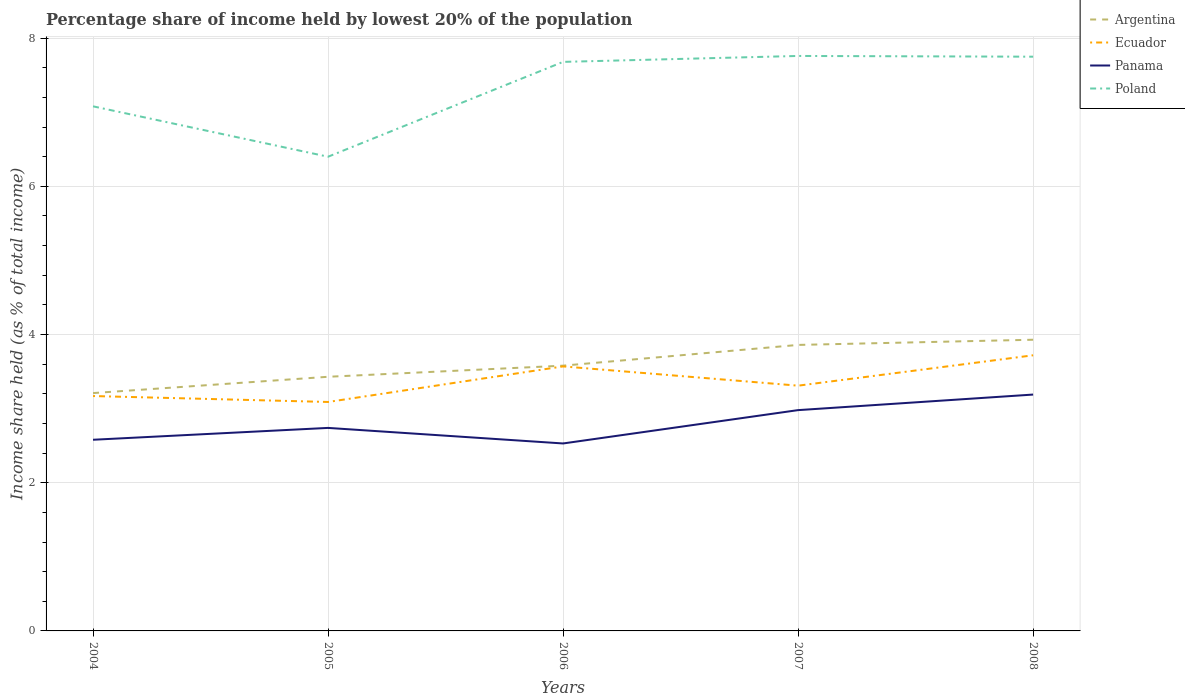Across all years, what is the maximum percentage share of income held by lowest 20% of the population in Poland?
Offer a terse response. 6.4. In which year was the percentage share of income held by lowest 20% of the population in Argentina maximum?
Make the answer very short. 2004. What is the total percentage share of income held by lowest 20% of the population in Argentina in the graph?
Give a very brief answer. -0.5. What is the difference between the highest and the second highest percentage share of income held by lowest 20% of the population in Argentina?
Your response must be concise. 0.72. What is the difference between the highest and the lowest percentage share of income held by lowest 20% of the population in Argentina?
Give a very brief answer. 2. What is the difference between two consecutive major ticks on the Y-axis?
Your response must be concise. 2. How are the legend labels stacked?
Your answer should be compact. Vertical. What is the title of the graph?
Make the answer very short. Percentage share of income held by lowest 20% of the population. What is the label or title of the X-axis?
Provide a succinct answer. Years. What is the label or title of the Y-axis?
Offer a very short reply. Income share held (as % of total income). What is the Income share held (as % of total income) in Argentina in 2004?
Ensure brevity in your answer.  3.21. What is the Income share held (as % of total income) in Ecuador in 2004?
Ensure brevity in your answer.  3.17. What is the Income share held (as % of total income) of Panama in 2004?
Provide a succinct answer. 2.58. What is the Income share held (as % of total income) in Poland in 2004?
Offer a very short reply. 7.08. What is the Income share held (as % of total income) of Argentina in 2005?
Give a very brief answer. 3.43. What is the Income share held (as % of total income) of Ecuador in 2005?
Your response must be concise. 3.09. What is the Income share held (as % of total income) in Panama in 2005?
Keep it short and to the point. 2.74. What is the Income share held (as % of total income) of Poland in 2005?
Provide a short and direct response. 6.4. What is the Income share held (as % of total income) in Argentina in 2006?
Provide a short and direct response. 3.58. What is the Income share held (as % of total income) in Ecuador in 2006?
Make the answer very short. 3.57. What is the Income share held (as % of total income) in Panama in 2006?
Offer a terse response. 2.53. What is the Income share held (as % of total income) of Poland in 2006?
Offer a terse response. 7.68. What is the Income share held (as % of total income) of Argentina in 2007?
Your answer should be compact. 3.86. What is the Income share held (as % of total income) in Ecuador in 2007?
Your response must be concise. 3.31. What is the Income share held (as % of total income) of Panama in 2007?
Keep it short and to the point. 2.98. What is the Income share held (as % of total income) in Poland in 2007?
Give a very brief answer. 7.76. What is the Income share held (as % of total income) of Argentina in 2008?
Ensure brevity in your answer.  3.93. What is the Income share held (as % of total income) of Ecuador in 2008?
Your answer should be compact. 3.72. What is the Income share held (as % of total income) in Panama in 2008?
Your answer should be very brief. 3.19. What is the Income share held (as % of total income) in Poland in 2008?
Offer a terse response. 7.75. Across all years, what is the maximum Income share held (as % of total income) in Argentina?
Your answer should be compact. 3.93. Across all years, what is the maximum Income share held (as % of total income) of Ecuador?
Give a very brief answer. 3.72. Across all years, what is the maximum Income share held (as % of total income) of Panama?
Your response must be concise. 3.19. Across all years, what is the maximum Income share held (as % of total income) in Poland?
Provide a succinct answer. 7.76. Across all years, what is the minimum Income share held (as % of total income) in Argentina?
Give a very brief answer. 3.21. Across all years, what is the minimum Income share held (as % of total income) in Ecuador?
Make the answer very short. 3.09. Across all years, what is the minimum Income share held (as % of total income) in Panama?
Provide a succinct answer. 2.53. Across all years, what is the minimum Income share held (as % of total income) in Poland?
Give a very brief answer. 6.4. What is the total Income share held (as % of total income) of Argentina in the graph?
Your answer should be compact. 18.01. What is the total Income share held (as % of total income) in Ecuador in the graph?
Ensure brevity in your answer.  16.86. What is the total Income share held (as % of total income) of Panama in the graph?
Ensure brevity in your answer.  14.02. What is the total Income share held (as % of total income) in Poland in the graph?
Make the answer very short. 36.67. What is the difference between the Income share held (as % of total income) in Argentina in 2004 and that in 2005?
Give a very brief answer. -0.22. What is the difference between the Income share held (as % of total income) of Panama in 2004 and that in 2005?
Give a very brief answer. -0.16. What is the difference between the Income share held (as % of total income) in Poland in 2004 and that in 2005?
Your answer should be very brief. 0.68. What is the difference between the Income share held (as % of total income) of Argentina in 2004 and that in 2006?
Make the answer very short. -0.37. What is the difference between the Income share held (as % of total income) of Panama in 2004 and that in 2006?
Your answer should be very brief. 0.05. What is the difference between the Income share held (as % of total income) of Poland in 2004 and that in 2006?
Keep it short and to the point. -0.6. What is the difference between the Income share held (as % of total income) in Argentina in 2004 and that in 2007?
Provide a short and direct response. -0.65. What is the difference between the Income share held (as % of total income) in Ecuador in 2004 and that in 2007?
Give a very brief answer. -0.14. What is the difference between the Income share held (as % of total income) of Panama in 2004 and that in 2007?
Make the answer very short. -0.4. What is the difference between the Income share held (as % of total income) in Poland in 2004 and that in 2007?
Make the answer very short. -0.68. What is the difference between the Income share held (as % of total income) of Argentina in 2004 and that in 2008?
Ensure brevity in your answer.  -0.72. What is the difference between the Income share held (as % of total income) in Ecuador in 2004 and that in 2008?
Keep it short and to the point. -0.55. What is the difference between the Income share held (as % of total income) in Panama in 2004 and that in 2008?
Your answer should be very brief. -0.61. What is the difference between the Income share held (as % of total income) in Poland in 2004 and that in 2008?
Provide a short and direct response. -0.67. What is the difference between the Income share held (as % of total income) in Ecuador in 2005 and that in 2006?
Ensure brevity in your answer.  -0.48. What is the difference between the Income share held (as % of total income) of Panama in 2005 and that in 2006?
Give a very brief answer. 0.21. What is the difference between the Income share held (as % of total income) of Poland in 2005 and that in 2006?
Provide a short and direct response. -1.28. What is the difference between the Income share held (as % of total income) of Argentina in 2005 and that in 2007?
Your answer should be compact. -0.43. What is the difference between the Income share held (as % of total income) of Ecuador in 2005 and that in 2007?
Offer a terse response. -0.22. What is the difference between the Income share held (as % of total income) in Panama in 2005 and that in 2007?
Ensure brevity in your answer.  -0.24. What is the difference between the Income share held (as % of total income) of Poland in 2005 and that in 2007?
Offer a very short reply. -1.36. What is the difference between the Income share held (as % of total income) of Argentina in 2005 and that in 2008?
Provide a succinct answer. -0.5. What is the difference between the Income share held (as % of total income) in Ecuador in 2005 and that in 2008?
Offer a very short reply. -0.63. What is the difference between the Income share held (as % of total income) of Panama in 2005 and that in 2008?
Give a very brief answer. -0.45. What is the difference between the Income share held (as % of total income) of Poland in 2005 and that in 2008?
Your response must be concise. -1.35. What is the difference between the Income share held (as % of total income) of Argentina in 2006 and that in 2007?
Make the answer very short. -0.28. What is the difference between the Income share held (as % of total income) in Ecuador in 2006 and that in 2007?
Make the answer very short. 0.26. What is the difference between the Income share held (as % of total income) in Panama in 2006 and that in 2007?
Keep it short and to the point. -0.45. What is the difference between the Income share held (as % of total income) of Poland in 2006 and that in 2007?
Your response must be concise. -0.08. What is the difference between the Income share held (as % of total income) in Argentina in 2006 and that in 2008?
Provide a succinct answer. -0.35. What is the difference between the Income share held (as % of total income) of Ecuador in 2006 and that in 2008?
Your answer should be very brief. -0.15. What is the difference between the Income share held (as % of total income) in Panama in 2006 and that in 2008?
Provide a short and direct response. -0.66. What is the difference between the Income share held (as % of total income) of Poland in 2006 and that in 2008?
Your answer should be compact. -0.07. What is the difference between the Income share held (as % of total income) in Argentina in 2007 and that in 2008?
Provide a succinct answer. -0.07. What is the difference between the Income share held (as % of total income) in Ecuador in 2007 and that in 2008?
Provide a succinct answer. -0.41. What is the difference between the Income share held (as % of total income) in Panama in 2007 and that in 2008?
Your response must be concise. -0.21. What is the difference between the Income share held (as % of total income) in Poland in 2007 and that in 2008?
Your answer should be compact. 0.01. What is the difference between the Income share held (as % of total income) of Argentina in 2004 and the Income share held (as % of total income) of Ecuador in 2005?
Offer a terse response. 0.12. What is the difference between the Income share held (as % of total income) of Argentina in 2004 and the Income share held (as % of total income) of Panama in 2005?
Your answer should be compact. 0.47. What is the difference between the Income share held (as % of total income) of Argentina in 2004 and the Income share held (as % of total income) of Poland in 2005?
Your answer should be very brief. -3.19. What is the difference between the Income share held (as % of total income) in Ecuador in 2004 and the Income share held (as % of total income) in Panama in 2005?
Provide a short and direct response. 0.43. What is the difference between the Income share held (as % of total income) of Ecuador in 2004 and the Income share held (as % of total income) of Poland in 2005?
Offer a very short reply. -3.23. What is the difference between the Income share held (as % of total income) of Panama in 2004 and the Income share held (as % of total income) of Poland in 2005?
Your answer should be compact. -3.82. What is the difference between the Income share held (as % of total income) in Argentina in 2004 and the Income share held (as % of total income) in Ecuador in 2006?
Keep it short and to the point. -0.36. What is the difference between the Income share held (as % of total income) of Argentina in 2004 and the Income share held (as % of total income) of Panama in 2006?
Your answer should be compact. 0.68. What is the difference between the Income share held (as % of total income) of Argentina in 2004 and the Income share held (as % of total income) of Poland in 2006?
Give a very brief answer. -4.47. What is the difference between the Income share held (as % of total income) of Ecuador in 2004 and the Income share held (as % of total income) of Panama in 2006?
Offer a very short reply. 0.64. What is the difference between the Income share held (as % of total income) of Ecuador in 2004 and the Income share held (as % of total income) of Poland in 2006?
Ensure brevity in your answer.  -4.51. What is the difference between the Income share held (as % of total income) in Argentina in 2004 and the Income share held (as % of total income) in Ecuador in 2007?
Ensure brevity in your answer.  -0.1. What is the difference between the Income share held (as % of total income) of Argentina in 2004 and the Income share held (as % of total income) of Panama in 2007?
Your answer should be compact. 0.23. What is the difference between the Income share held (as % of total income) in Argentina in 2004 and the Income share held (as % of total income) in Poland in 2007?
Your answer should be very brief. -4.55. What is the difference between the Income share held (as % of total income) of Ecuador in 2004 and the Income share held (as % of total income) of Panama in 2007?
Offer a terse response. 0.19. What is the difference between the Income share held (as % of total income) of Ecuador in 2004 and the Income share held (as % of total income) of Poland in 2007?
Your answer should be very brief. -4.59. What is the difference between the Income share held (as % of total income) in Panama in 2004 and the Income share held (as % of total income) in Poland in 2007?
Provide a succinct answer. -5.18. What is the difference between the Income share held (as % of total income) in Argentina in 2004 and the Income share held (as % of total income) in Ecuador in 2008?
Make the answer very short. -0.51. What is the difference between the Income share held (as % of total income) in Argentina in 2004 and the Income share held (as % of total income) in Panama in 2008?
Keep it short and to the point. 0.02. What is the difference between the Income share held (as % of total income) of Argentina in 2004 and the Income share held (as % of total income) of Poland in 2008?
Give a very brief answer. -4.54. What is the difference between the Income share held (as % of total income) in Ecuador in 2004 and the Income share held (as % of total income) in Panama in 2008?
Give a very brief answer. -0.02. What is the difference between the Income share held (as % of total income) of Ecuador in 2004 and the Income share held (as % of total income) of Poland in 2008?
Make the answer very short. -4.58. What is the difference between the Income share held (as % of total income) of Panama in 2004 and the Income share held (as % of total income) of Poland in 2008?
Your answer should be compact. -5.17. What is the difference between the Income share held (as % of total income) of Argentina in 2005 and the Income share held (as % of total income) of Ecuador in 2006?
Ensure brevity in your answer.  -0.14. What is the difference between the Income share held (as % of total income) of Argentina in 2005 and the Income share held (as % of total income) of Panama in 2006?
Make the answer very short. 0.9. What is the difference between the Income share held (as % of total income) of Argentina in 2005 and the Income share held (as % of total income) of Poland in 2006?
Give a very brief answer. -4.25. What is the difference between the Income share held (as % of total income) of Ecuador in 2005 and the Income share held (as % of total income) of Panama in 2006?
Provide a short and direct response. 0.56. What is the difference between the Income share held (as % of total income) in Ecuador in 2005 and the Income share held (as % of total income) in Poland in 2006?
Give a very brief answer. -4.59. What is the difference between the Income share held (as % of total income) of Panama in 2005 and the Income share held (as % of total income) of Poland in 2006?
Provide a succinct answer. -4.94. What is the difference between the Income share held (as % of total income) of Argentina in 2005 and the Income share held (as % of total income) of Ecuador in 2007?
Offer a very short reply. 0.12. What is the difference between the Income share held (as % of total income) of Argentina in 2005 and the Income share held (as % of total income) of Panama in 2007?
Give a very brief answer. 0.45. What is the difference between the Income share held (as % of total income) of Argentina in 2005 and the Income share held (as % of total income) of Poland in 2007?
Offer a very short reply. -4.33. What is the difference between the Income share held (as % of total income) of Ecuador in 2005 and the Income share held (as % of total income) of Panama in 2007?
Ensure brevity in your answer.  0.11. What is the difference between the Income share held (as % of total income) of Ecuador in 2005 and the Income share held (as % of total income) of Poland in 2007?
Give a very brief answer. -4.67. What is the difference between the Income share held (as % of total income) of Panama in 2005 and the Income share held (as % of total income) of Poland in 2007?
Provide a short and direct response. -5.02. What is the difference between the Income share held (as % of total income) of Argentina in 2005 and the Income share held (as % of total income) of Ecuador in 2008?
Give a very brief answer. -0.29. What is the difference between the Income share held (as % of total income) of Argentina in 2005 and the Income share held (as % of total income) of Panama in 2008?
Make the answer very short. 0.24. What is the difference between the Income share held (as % of total income) in Argentina in 2005 and the Income share held (as % of total income) in Poland in 2008?
Provide a short and direct response. -4.32. What is the difference between the Income share held (as % of total income) in Ecuador in 2005 and the Income share held (as % of total income) in Poland in 2008?
Provide a short and direct response. -4.66. What is the difference between the Income share held (as % of total income) in Panama in 2005 and the Income share held (as % of total income) in Poland in 2008?
Your answer should be compact. -5.01. What is the difference between the Income share held (as % of total income) in Argentina in 2006 and the Income share held (as % of total income) in Ecuador in 2007?
Make the answer very short. 0.27. What is the difference between the Income share held (as % of total income) of Argentina in 2006 and the Income share held (as % of total income) of Poland in 2007?
Offer a very short reply. -4.18. What is the difference between the Income share held (as % of total income) in Ecuador in 2006 and the Income share held (as % of total income) in Panama in 2007?
Provide a succinct answer. 0.59. What is the difference between the Income share held (as % of total income) in Ecuador in 2006 and the Income share held (as % of total income) in Poland in 2007?
Offer a very short reply. -4.19. What is the difference between the Income share held (as % of total income) in Panama in 2006 and the Income share held (as % of total income) in Poland in 2007?
Your response must be concise. -5.23. What is the difference between the Income share held (as % of total income) in Argentina in 2006 and the Income share held (as % of total income) in Ecuador in 2008?
Keep it short and to the point. -0.14. What is the difference between the Income share held (as % of total income) in Argentina in 2006 and the Income share held (as % of total income) in Panama in 2008?
Provide a succinct answer. 0.39. What is the difference between the Income share held (as % of total income) of Argentina in 2006 and the Income share held (as % of total income) of Poland in 2008?
Your answer should be very brief. -4.17. What is the difference between the Income share held (as % of total income) in Ecuador in 2006 and the Income share held (as % of total income) in Panama in 2008?
Your answer should be compact. 0.38. What is the difference between the Income share held (as % of total income) in Ecuador in 2006 and the Income share held (as % of total income) in Poland in 2008?
Keep it short and to the point. -4.18. What is the difference between the Income share held (as % of total income) in Panama in 2006 and the Income share held (as % of total income) in Poland in 2008?
Provide a short and direct response. -5.22. What is the difference between the Income share held (as % of total income) in Argentina in 2007 and the Income share held (as % of total income) in Ecuador in 2008?
Offer a terse response. 0.14. What is the difference between the Income share held (as % of total income) in Argentina in 2007 and the Income share held (as % of total income) in Panama in 2008?
Provide a short and direct response. 0.67. What is the difference between the Income share held (as % of total income) in Argentina in 2007 and the Income share held (as % of total income) in Poland in 2008?
Give a very brief answer. -3.89. What is the difference between the Income share held (as % of total income) in Ecuador in 2007 and the Income share held (as % of total income) in Panama in 2008?
Give a very brief answer. 0.12. What is the difference between the Income share held (as % of total income) of Ecuador in 2007 and the Income share held (as % of total income) of Poland in 2008?
Provide a short and direct response. -4.44. What is the difference between the Income share held (as % of total income) of Panama in 2007 and the Income share held (as % of total income) of Poland in 2008?
Provide a short and direct response. -4.77. What is the average Income share held (as % of total income) in Argentina per year?
Provide a short and direct response. 3.6. What is the average Income share held (as % of total income) of Ecuador per year?
Provide a succinct answer. 3.37. What is the average Income share held (as % of total income) in Panama per year?
Your response must be concise. 2.8. What is the average Income share held (as % of total income) of Poland per year?
Give a very brief answer. 7.33. In the year 2004, what is the difference between the Income share held (as % of total income) in Argentina and Income share held (as % of total income) in Ecuador?
Keep it short and to the point. 0.04. In the year 2004, what is the difference between the Income share held (as % of total income) in Argentina and Income share held (as % of total income) in Panama?
Keep it short and to the point. 0.63. In the year 2004, what is the difference between the Income share held (as % of total income) of Argentina and Income share held (as % of total income) of Poland?
Give a very brief answer. -3.87. In the year 2004, what is the difference between the Income share held (as % of total income) in Ecuador and Income share held (as % of total income) in Panama?
Offer a terse response. 0.59. In the year 2004, what is the difference between the Income share held (as % of total income) of Ecuador and Income share held (as % of total income) of Poland?
Your answer should be very brief. -3.91. In the year 2004, what is the difference between the Income share held (as % of total income) in Panama and Income share held (as % of total income) in Poland?
Your response must be concise. -4.5. In the year 2005, what is the difference between the Income share held (as % of total income) in Argentina and Income share held (as % of total income) in Ecuador?
Offer a terse response. 0.34. In the year 2005, what is the difference between the Income share held (as % of total income) in Argentina and Income share held (as % of total income) in Panama?
Give a very brief answer. 0.69. In the year 2005, what is the difference between the Income share held (as % of total income) of Argentina and Income share held (as % of total income) of Poland?
Offer a very short reply. -2.97. In the year 2005, what is the difference between the Income share held (as % of total income) in Ecuador and Income share held (as % of total income) in Poland?
Your answer should be compact. -3.31. In the year 2005, what is the difference between the Income share held (as % of total income) of Panama and Income share held (as % of total income) of Poland?
Your response must be concise. -3.66. In the year 2006, what is the difference between the Income share held (as % of total income) in Argentina and Income share held (as % of total income) in Ecuador?
Offer a terse response. 0.01. In the year 2006, what is the difference between the Income share held (as % of total income) in Argentina and Income share held (as % of total income) in Poland?
Your response must be concise. -4.1. In the year 2006, what is the difference between the Income share held (as % of total income) in Ecuador and Income share held (as % of total income) in Poland?
Provide a succinct answer. -4.11. In the year 2006, what is the difference between the Income share held (as % of total income) of Panama and Income share held (as % of total income) of Poland?
Your answer should be very brief. -5.15. In the year 2007, what is the difference between the Income share held (as % of total income) of Argentina and Income share held (as % of total income) of Ecuador?
Ensure brevity in your answer.  0.55. In the year 2007, what is the difference between the Income share held (as % of total income) in Ecuador and Income share held (as % of total income) in Panama?
Your answer should be compact. 0.33. In the year 2007, what is the difference between the Income share held (as % of total income) in Ecuador and Income share held (as % of total income) in Poland?
Give a very brief answer. -4.45. In the year 2007, what is the difference between the Income share held (as % of total income) in Panama and Income share held (as % of total income) in Poland?
Your response must be concise. -4.78. In the year 2008, what is the difference between the Income share held (as % of total income) of Argentina and Income share held (as % of total income) of Ecuador?
Make the answer very short. 0.21. In the year 2008, what is the difference between the Income share held (as % of total income) in Argentina and Income share held (as % of total income) in Panama?
Your response must be concise. 0.74. In the year 2008, what is the difference between the Income share held (as % of total income) of Argentina and Income share held (as % of total income) of Poland?
Keep it short and to the point. -3.82. In the year 2008, what is the difference between the Income share held (as % of total income) in Ecuador and Income share held (as % of total income) in Panama?
Ensure brevity in your answer.  0.53. In the year 2008, what is the difference between the Income share held (as % of total income) in Ecuador and Income share held (as % of total income) in Poland?
Provide a short and direct response. -4.03. In the year 2008, what is the difference between the Income share held (as % of total income) in Panama and Income share held (as % of total income) in Poland?
Provide a succinct answer. -4.56. What is the ratio of the Income share held (as % of total income) of Argentina in 2004 to that in 2005?
Offer a very short reply. 0.94. What is the ratio of the Income share held (as % of total income) in Ecuador in 2004 to that in 2005?
Offer a very short reply. 1.03. What is the ratio of the Income share held (as % of total income) in Panama in 2004 to that in 2005?
Make the answer very short. 0.94. What is the ratio of the Income share held (as % of total income) of Poland in 2004 to that in 2005?
Your answer should be compact. 1.11. What is the ratio of the Income share held (as % of total income) of Argentina in 2004 to that in 2006?
Give a very brief answer. 0.9. What is the ratio of the Income share held (as % of total income) of Ecuador in 2004 to that in 2006?
Offer a terse response. 0.89. What is the ratio of the Income share held (as % of total income) in Panama in 2004 to that in 2006?
Give a very brief answer. 1.02. What is the ratio of the Income share held (as % of total income) of Poland in 2004 to that in 2006?
Offer a terse response. 0.92. What is the ratio of the Income share held (as % of total income) in Argentina in 2004 to that in 2007?
Ensure brevity in your answer.  0.83. What is the ratio of the Income share held (as % of total income) in Ecuador in 2004 to that in 2007?
Your answer should be very brief. 0.96. What is the ratio of the Income share held (as % of total income) in Panama in 2004 to that in 2007?
Provide a succinct answer. 0.87. What is the ratio of the Income share held (as % of total income) of Poland in 2004 to that in 2007?
Offer a terse response. 0.91. What is the ratio of the Income share held (as % of total income) of Argentina in 2004 to that in 2008?
Offer a terse response. 0.82. What is the ratio of the Income share held (as % of total income) in Ecuador in 2004 to that in 2008?
Offer a terse response. 0.85. What is the ratio of the Income share held (as % of total income) of Panama in 2004 to that in 2008?
Give a very brief answer. 0.81. What is the ratio of the Income share held (as % of total income) of Poland in 2004 to that in 2008?
Offer a terse response. 0.91. What is the ratio of the Income share held (as % of total income) in Argentina in 2005 to that in 2006?
Offer a terse response. 0.96. What is the ratio of the Income share held (as % of total income) in Ecuador in 2005 to that in 2006?
Your response must be concise. 0.87. What is the ratio of the Income share held (as % of total income) in Panama in 2005 to that in 2006?
Your answer should be compact. 1.08. What is the ratio of the Income share held (as % of total income) of Argentina in 2005 to that in 2007?
Your response must be concise. 0.89. What is the ratio of the Income share held (as % of total income) in Ecuador in 2005 to that in 2007?
Provide a succinct answer. 0.93. What is the ratio of the Income share held (as % of total income) in Panama in 2005 to that in 2007?
Your answer should be compact. 0.92. What is the ratio of the Income share held (as % of total income) in Poland in 2005 to that in 2007?
Offer a very short reply. 0.82. What is the ratio of the Income share held (as % of total income) in Argentina in 2005 to that in 2008?
Ensure brevity in your answer.  0.87. What is the ratio of the Income share held (as % of total income) in Ecuador in 2005 to that in 2008?
Offer a terse response. 0.83. What is the ratio of the Income share held (as % of total income) in Panama in 2005 to that in 2008?
Your answer should be very brief. 0.86. What is the ratio of the Income share held (as % of total income) of Poland in 2005 to that in 2008?
Keep it short and to the point. 0.83. What is the ratio of the Income share held (as % of total income) in Argentina in 2006 to that in 2007?
Offer a terse response. 0.93. What is the ratio of the Income share held (as % of total income) of Ecuador in 2006 to that in 2007?
Keep it short and to the point. 1.08. What is the ratio of the Income share held (as % of total income) of Panama in 2006 to that in 2007?
Make the answer very short. 0.85. What is the ratio of the Income share held (as % of total income) in Poland in 2006 to that in 2007?
Make the answer very short. 0.99. What is the ratio of the Income share held (as % of total income) in Argentina in 2006 to that in 2008?
Make the answer very short. 0.91. What is the ratio of the Income share held (as % of total income) of Ecuador in 2006 to that in 2008?
Your answer should be very brief. 0.96. What is the ratio of the Income share held (as % of total income) in Panama in 2006 to that in 2008?
Keep it short and to the point. 0.79. What is the ratio of the Income share held (as % of total income) in Poland in 2006 to that in 2008?
Your answer should be compact. 0.99. What is the ratio of the Income share held (as % of total income) of Argentina in 2007 to that in 2008?
Offer a terse response. 0.98. What is the ratio of the Income share held (as % of total income) of Ecuador in 2007 to that in 2008?
Keep it short and to the point. 0.89. What is the ratio of the Income share held (as % of total income) in Panama in 2007 to that in 2008?
Keep it short and to the point. 0.93. What is the ratio of the Income share held (as % of total income) of Poland in 2007 to that in 2008?
Offer a terse response. 1. What is the difference between the highest and the second highest Income share held (as % of total income) in Argentina?
Give a very brief answer. 0.07. What is the difference between the highest and the second highest Income share held (as % of total income) of Ecuador?
Offer a terse response. 0.15. What is the difference between the highest and the second highest Income share held (as % of total income) of Panama?
Give a very brief answer. 0.21. What is the difference between the highest and the second highest Income share held (as % of total income) of Poland?
Provide a succinct answer. 0.01. What is the difference between the highest and the lowest Income share held (as % of total income) of Argentina?
Provide a succinct answer. 0.72. What is the difference between the highest and the lowest Income share held (as % of total income) of Ecuador?
Keep it short and to the point. 0.63. What is the difference between the highest and the lowest Income share held (as % of total income) in Panama?
Provide a short and direct response. 0.66. What is the difference between the highest and the lowest Income share held (as % of total income) in Poland?
Offer a very short reply. 1.36. 